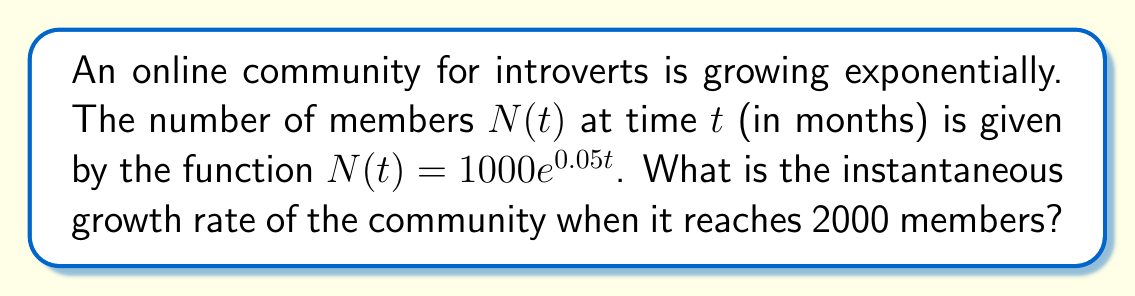What is the answer to this math problem? To solve this problem, we'll follow these steps:

1) First, we need to find the time $t$ when the community reaches 2000 members:
   $$2000 = 1000e^{0.05t}$$
   $$2 = e^{0.05t}$$
   $$\ln(2) = 0.05t$$
   $$t = \frac{\ln(2)}{0.05} \approx 13.86 \text{ months}$$

2) The instantaneous growth rate is given by the derivative of $N(t)$ with respect to $t$:
   $$\frac{dN}{dt} = 1000 \cdot 0.05e^{0.05t}$$

3) To find the growth rate when there are 2000 members, we substitute $t = \frac{\ln(2)}{0.05}$ into this derivative:
   $$\frac{dN}{dt} = 1000 \cdot 0.05e^{0.05(\frac{\ln(2)}{0.05})}$$
   $$= 1000 \cdot 0.05e^{\ln(2)}$$
   $$= 1000 \cdot 0.05 \cdot 2$$
   $$= 100 \text{ members/month}$$

Therefore, when the community reaches 2000 members, it's growing at a rate of 100 members per month.
Answer: 100 members/month 